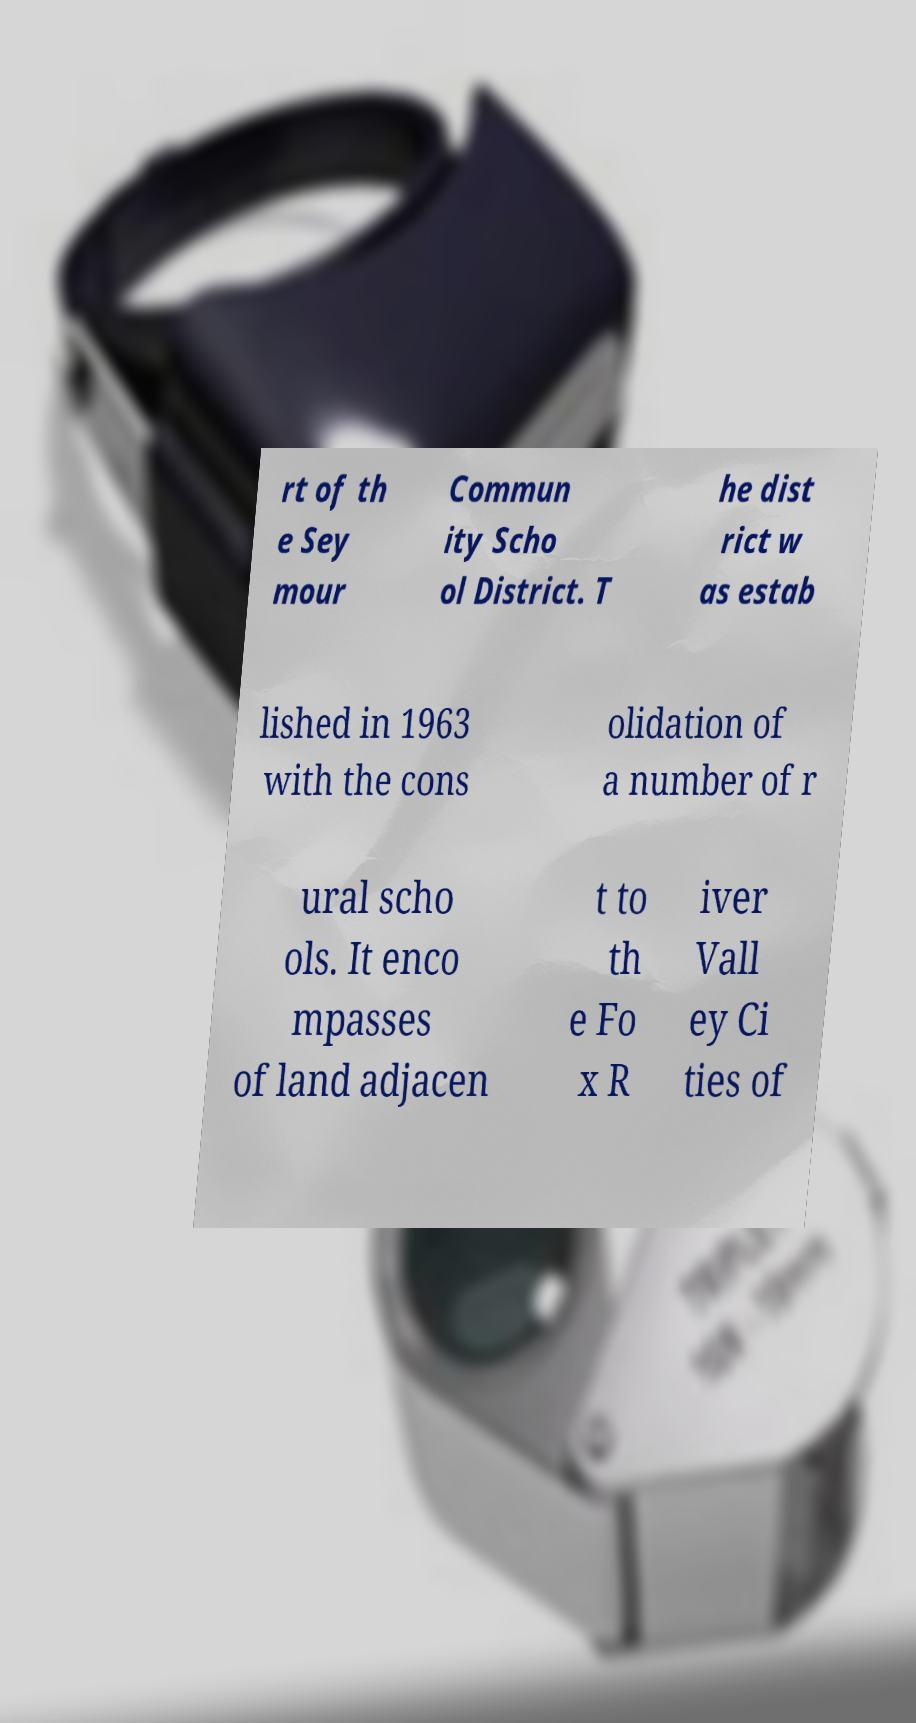Please identify and transcribe the text found in this image. rt of th e Sey mour Commun ity Scho ol District. T he dist rict w as estab lished in 1963 with the cons olidation of a number of r ural scho ols. It enco mpasses of land adjacen t to th e Fo x R iver Vall ey Ci ties of 